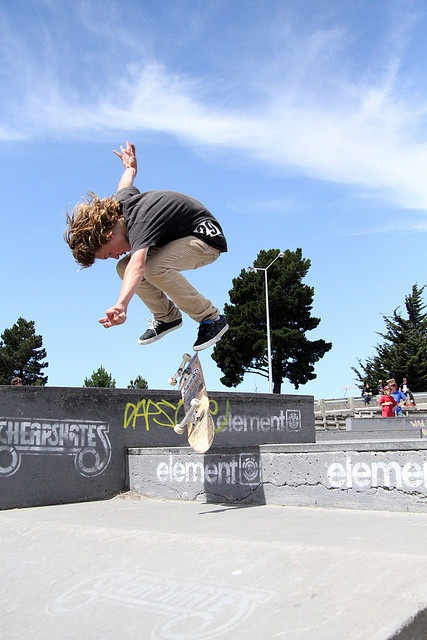Describe the objects in this image and their specific colors. I can see people in gray, black, and darkgray tones, skateboard in gray, ivory, darkgray, and tan tones, people in gray, brown, maroon, and salmon tones, people in gray, darkblue, lightblue, and darkgray tones, and people in gray, black, white, and darkgray tones in this image. 